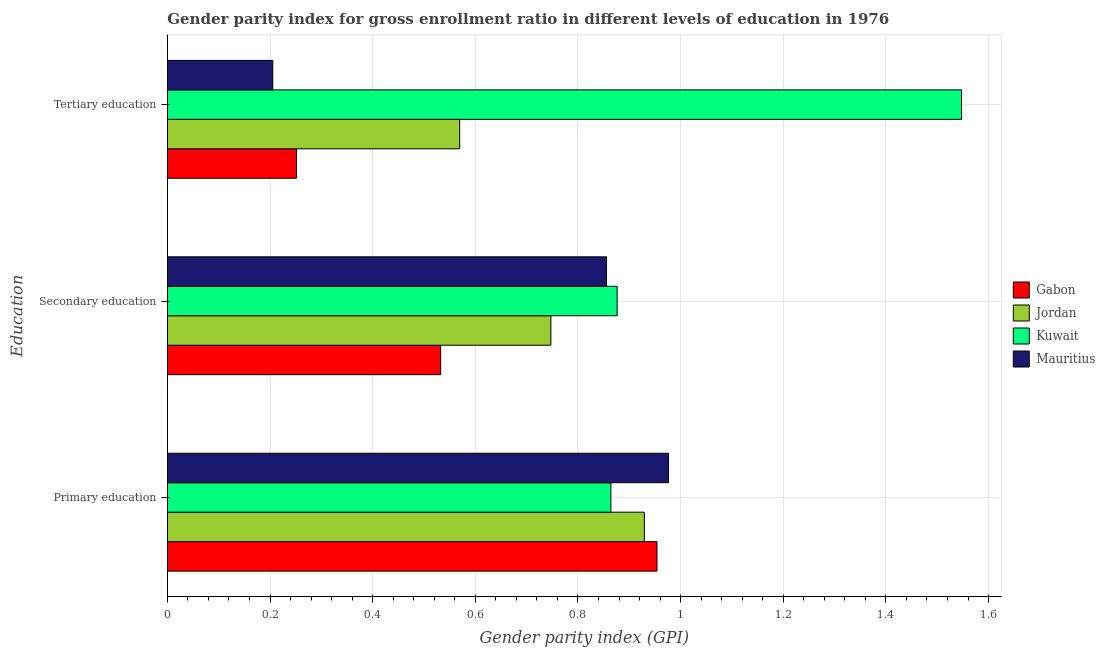How many groups of bars are there?
Provide a succinct answer. 3. Are the number of bars on each tick of the Y-axis equal?
Make the answer very short. Yes. How many bars are there on the 3rd tick from the top?
Keep it short and to the point. 4. What is the gender parity index in tertiary education in Gabon?
Ensure brevity in your answer.  0.25. Across all countries, what is the maximum gender parity index in secondary education?
Ensure brevity in your answer.  0.88. Across all countries, what is the minimum gender parity index in primary education?
Give a very brief answer. 0.86. In which country was the gender parity index in tertiary education maximum?
Make the answer very short. Kuwait. In which country was the gender parity index in tertiary education minimum?
Ensure brevity in your answer.  Mauritius. What is the total gender parity index in secondary education in the graph?
Make the answer very short. 3.01. What is the difference between the gender parity index in tertiary education in Mauritius and that in Gabon?
Keep it short and to the point. -0.05. What is the difference between the gender parity index in secondary education in Jordan and the gender parity index in tertiary education in Mauritius?
Provide a succinct answer. 0.54. What is the average gender parity index in primary education per country?
Offer a terse response. 0.93. What is the difference between the gender parity index in secondary education and gender parity index in primary education in Mauritius?
Offer a very short reply. -0.12. In how many countries, is the gender parity index in secondary education greater than 0.92 ?
Your response must be concise. 0. What is the ratio of the gender parity index in tertiary education in Jordan to that in Kuwait?
Your response must be concise. 0.37. Is the difference between the gender parity index in secondary education in Jordan and Kuwait greater than the difference between the gender parity index in tertiary education in Jordan and Kuwait?
Your response must be concise. Yes. What is the difference between the highest and the second highest gender parity index in primary education?
Give a very brief answer. 0.02. What is the difference between the highest and the lowest gender parity index in secondary education?
Offer a terse response. 0.34. Is the sum of the gender parity index in primary education in Kuwait and Gabon greater than the maximum gender parity index in secondary education across all countries?
Provide a short and direct response. Yes. What does the 1st bar from the top in Primary education represents?
Your answer should be very brief. Mauritius. What does the 2nd bar from the bottom in Tertiary education represents?
Give a very brief answer. Jordan. What is the difference between two consecutive major ticks on the X-axis?
Offer a terse response. 0.2. Does the graph contain grids?
Offer a terse response. Yes. What is the title of the graph?
Your answer should be very brief. Gender parity index for gross enrollment ratio in different levels of education in 1976. What is the label or title of the X-axis?
Your answer should be compact. Gender parity index (GPI). What is the label or title of the Y-axis?
Your answer should be very brief. Education. What is the Gender parity index (GPI) in Gabon in Primary education?
Keep it short and to the point. 0.95. What is the Gender parity index (GPI) in Jordan in Primary education?
Provide a succinct answer. 0.93. What is the Gender parity index (GPI) in Kuwait in Primary education?
Your response must be concise. 0.86. What is the Gender parity index (GPI) in Mauritius in Primary education?
Provide a succinct answer. 0.98. What is the Gender parity index (GPI) in Gabon in Secondary education?
Your answer should be very brief. 0.53. What is the Gender parity index (GPI) of Jordan in Secondary education?
Offer a very short reply. 0.75. What is the Gender parity index (GPI) in Kuwait in Secondary education?
Your response must be concise. 0.88. What is the Gender parity index (GPI) of Mauritius in Secondary education?
Give a very brief answer. 0.86. What is the Gender parity index (GPI) of Gabon in Tertiary education?
Provide a short and direct response. 0.25. What is the Gender parity index (GPI) of Jordan in Tertiary education?
Provide a short and direct response. 0.57. What is the Gender parity index (GPI) of Kuwait in Tertiary education?
Provide a succinct answer. 1.55. What is the Gender parity index (GPI) in Mauritius in Tertiary education?
Make the answer very short. 0.21. Across all Education, what is the maximum Gender parity index (GPI) of Gabon?
Offer a very short reply. 0.95. Across all Education, what is the maximum Gender parity index (GPI) in Jordan?
Provide a succinct answer. 0.93. Across all Education, what is the maximum Gender parity index (GPI) in Kuwait?
Provide a succinct answer. 1.55. Across all Education, what is the maximum Gender parity index (GPI) of Mauritius?
Make the answer very short. 0.98. Across all Education, what is the minimum Gender parity index (GPI) of Gabon?
Offer a terse response. 0.25. Across all Education, what is the minimum Gender parity index (GPI) in Jordan?
Provide a succinct answer. 0.57. Across all Education, what is the minimum Gender parity index (GPI) of Kuwait?
Offer a very short reply. 0.86. Across all Education, what is the minimum Gender parity index (GPI) of Mauritius?
Your answer should be very brief. 0.21. What is the total Gender parity index (GPI) of Gabon in the graph?
Keep it short and to the point. 1.74. What is the total Gender parity index (GPI) in Jordan in the graph?
Provide a succinct answer. 2.25. What is the total Gender parity index (GPI) of Kuwait in the graph?
Your response must be concise. 3.29. What is the total Gender parity index (GPI) in Mauritius in the graph?
Provide a short and direct response. 2.04. What is the difference between the Gender parity index (GPI) of Gabon in Primary education and that in Secondary education?
Offer a very short reply. 0.42. What is the difference between the Gender parity index (GPI) of Jordan in Primary education and that in Secondary education?
Provide a short and direct response. 0.18. What is the difference between the Gender parity index (GPI) of Kuwait in Primary education and that in Secondary education?
Make the answer very short. -0.01. What is the difference between the Gender parity index (GPI) in Mauritius in Primary education and that in Secondary education?
Ensure brevity in your answer.  0.12. What is the difference between the Gender parity index (GPI) of Gabon in Primary education and that in Tertiary education?
Your answer should be compact. 0.7. What is the difference between the Gender parity index (GPI) in Jordan in Primary education and that in Tertiary education?
Make the answer very short. 0.36. What is the difference between the Gender parity index (GPI) of Kuwait in Primary education and that in Tertiary education?
Give a very brief answer. -0.68. What is the difference between the Gender parity index (GPI) of Mauritius in Primary education and that in Tertiary education?
Your answer should be compact. 0.77. What is the difference between the Gender parity index (GPI) of Gabon in Secondary education and that in Tertiary education?
Offer a very short reply. 0.28. What is the difference between the Gender parity index (GPI) of Jordan in Secondary education and that in Tertiary education?
Give a very brief answer. 0.18. What is the difference between the Gender parity index (GPI) of Kuwait in Secondary education and that in Tertiary education?
Offer a very short reply. -0.67. What is the difference between the Gender parity index (GPI) of Mauritius in Secondary education and that in Tertiary education?
Offer a very short reply. 0.65. What is the difference between the Gender parity index (GPI) in Gabon in Primary education and the Gender parity index (GPI) in Jordan in Secondary education?
Ensure brevity in your answer.  0.21. What is the difference between the Gender parity index (GPI) of Gabon in Primary education and the Gender parity index (GPI) of Kuwait in Secondary education?
Your response must be concise. 0.08. What is the difference between the Gender parity index (GPI) in Gabon in Primary education and the Gender parity index (GPI) in Mauritius in Secondary education?
Provide a short and direct response. 0.1. What is the difference between the Gender parity index (GPI) of Jordan in Primary education and the Gender parity index (GPI) of Kuwait in Secondary education?
Ensure brevity in your answer.  0.05. What is the difference between the Gender parity index (GPI) of Jordan in Primary education and the Gender parity index (GPI) of Mauritius in Secondary education?
Your response must be concise. 0.07. What is the difference between the Gender parity index (GPI) of Kuwait in Primary education and the Gender parity index (GPI) of Mauritius in Secondary education?
Your answer should be very brief. 0.01. What is the difference between the Gender parity index (GPI) of Gabon in Primary education and the Gender parity index (GPI) of Jordan in Tertiary education?
Make the answer very short. 0.38. What is the difference between the Gender parity index (GPI) in Gabon in Primary education and the Gender parity index (GPI) in Kuwait in Tertiary education?
Offer a terse response. -0.59. What is the difference between the Gender parity index (GPI) of Gabon in Primary education and the Gender parity index (GPI) of Mauritius in Tertiary education?
Offer a very short reply. 0.75. What is the difference between the Gender parity index (GPI) in Jordan in Primary education and the Gender parity index (GPI) in Kuwait in Tertiary education?
Make the answer very short. -0.62. What is the difference between the Gender parity index (GPI) in Jordan in Primary education and the Gender parity index (GPI) in Mauritius in Tertiary education?
Offer a very short reply. 0.72. What is the difference between the Gender parity index (GPI) in Kuwait in Primary education and the Gender parity index (GPI) in Mauritius in Tertiary education?
Your answer should be very brief. 0.66. What is the difference between the Gender parity index (GPI) in Gabon in Secondary education and the Gender parity index (GPI) in Jordan in Tertiary education?
Provide a succinct answer. -0.04. What is the difference between the Gender parity index (GPI) of Gabon in Secondary education and the Gender parity index (GPI) of Kuwait in Tertiary education?
Keep it short and to the point. -1.01. What is the difference between the Gender parity index (GPI) in Gabon in Secondary education and the Gender parity index (GPI) in Mauritius in Tertiary education?
Offer a very short reply. 0.33. What is the difference between the Gender parity index (GPI) of Jordan in Secondary education and the Gender parity index (GPI) of Kuwait in Tertiary education?
Make the answer very short. -0.8. What is the difference between the Gender parity index (GPI) in Jordan in Secondary education and the Gender parity index (GPI) in Mauritius in Tertiary education?
Your answer should be compact. 0.54. What is the difference between the Gender parity index (GPI) in Kuwait in Secondary education and the Gender parity index (GPI) in Mauritius in Tertiary education?
Offer a very short reply. 0.67. What is the average Gender parity index (GPI) in Gabon per Education?
Your response must be concise. 0.58. What is the average Gender parity index (GPI) in Jordan per Education?
Provide a succinct answer. 0.75. What is the average Gender parity index (GPI) in Kuwait per Education?
Provide a succinct answer. 1.1. What is the average Gender parity index (GPI) of Mauritius per Education?
Offer a terse response. 0.68. What is the difference between the Gender parity index (GPI) of Gabon and Gender parity index (GPI) of Jordan in Primary education?
Your answer should be very brief. 0.02. What is the difference between the Gender parity index (GPI) in Gabon and Gender parity index (GPI) in Kuwait in Primary education?
Offer a very short reply. 0.09. What is the difference between the Gender parity index (GPI) of Gabon and Gender parity index (GPI) of Mauritius in Primary education?
Your response must be concise. -0.02. What is the difference between the Gender parity index (GPI) in Jordan and Gender parity index (GPI) in Kuwait in Primary education?
Keep it short and to the point. 0.07. What is the difference between the Gender parity index (GPI) of Jordan and Gender parity index (GPI) of Mauritius in Primary education?
Your answer should be compact. -0.05. What is the difference between the Gender parity index (GPI) in Kuwait and Gender parity index (GPI) in Mauritius in Primary education?
Your answer should be compact. -0.11. What is the difference between the Gender parity index (GPI) of Gabon and Gender parity index (GPI) of Jordan in Secondary education?
Give a very brief answer. -0.21. What is the difference between the Gender parity index (GPI) of Gabon and Gender parity index (GPI) of Kuwait in Secondary education?
Your answer should be compact. -0.34. What is the difference between the Gender parity index (GPI) of Gabon and Gender parity index (GPI) of Mauritius in Secondary education?
Offer a very short reply. -0.32. What is the difference between the Gender parity index (GPI) in Jordan and Gender parity index (GPI) in Kuwait in Secondary education?
Your answer should be very brief. -0.13. What is the difference between the Gender parity index (GPI) of Jordan and Gender parity index (GPI) of Mauritius in Secondary education?
Make the answer very short. -0.11. What is the difference between the Gender parity index (GPI) of Kuwait and Gender parity index (GPI) of Mauritius in Secondary education?
Provide a short and direct response. 0.02. What is the difference between the Gender parity index (GPI) of Gabon and Gender parity index (GPI) of Jordan in Tertiary education?
Your response must be concise. -0.32. What is the difference between the Gender parity index (GPI) of Gabon and Gender parity index (GPI) of Kuwait in Tertiary education?
Your answer should be compact. -1.3. What is the difference between the Gender parity index (GPI) of Gabon and Gender parity index (GPI) of Mauritius in Tertiary education?
Your answer should be compact. 0.05. What is the difference between the Gender parity index (GPI) in Jordan and Gender parity index (GPI) in Kuwait in Tertiary education?
Keep it short and to the point. -0.98. What is the difference between the Gender parity index (GPI) of Jordan and Gender parity index (GPI) of Mauritius in Tertiary education?
Ensure brevity in your answer.  0.36. What is the difference between the Gender parity index (GPI) of Kuwait and Gender parity index (GPI) of Mauritius in Tertiary education?
Provide a succinct answer. 1.34. What is the ratio of the Gender parity index (GPI) of Gabon in Primary education to that in Secondary education?
Ensure brevity in your answer.  1.79. What is the ratio of the Gender parity index (GPI) of Jordan in Primary education to that in Secondary education?
Your response must be concise. 1.24. What is the ratio of the Gender parity index (GPI) of Kuwait in Primary education to that in Secondary education?
Your answer should be compact. 0.99. What is the ratio of the Gender parity index (GPI) of Mauritius in Primary education to that in Secondary education?
Make the answer very short. 1.14. What is the ratio of the Gender parity index (GPI) in Gabon in Primary education to that in Tertiary education?
Keep it short and to the point. 3.79. What is the ratio of the Gender parity index (GPI) of Jordan in Primary education to that in Tertiary education?
Your answer should be compact. 1.63. What is the ratio of the Gender parity index (GPI) of Kuwait in Primary education to that in Tertiary education?
Ensure brevity in your answer.  0.56. What is the ratio of the Gender parity index (GPI) of Mauritius in Primary education to that in Tertiary education?
Offer a very short reply. 4.75. What is the ratio of the Gender parity index (GPI) in Gabon in Secondary education to that in Tertiary education?
Keep it short and to the point. 2.12. What is the ratio of the Gender parity index (GPI) in Jordan in Secondary education to that in Tertiary education?
Ensure brevity in your answer.  1.31. What is the ratio of the Gender parity index (GPI) in Kuwait in Secondary education to that in Tertiary education?
Offer a very short reply. 0.57. What is the ratio of the Gender parity index (GPI) in Mauritius in Secondary education to that in Tertiary education?
Keep it short and to the point. 4.17. What is the difference between the highest and the second highest Gender parity index (GPI) of Gabon?
Provide a succinct answer. 0.42. What is the difference between the highest and the second highest Gender parity index (GPI) in Jordan?
Offer a terse response. 0.18. What is the difference between the highest and the second highest Gender parity index (GPI) in Kuwait?
Offer a terse response. 0.67. What is the difference between the highest and the second highest Gender parity index (GPI) of Mauritius?
Provide a succinct answer. 0.12. What is the difference between the highest and the lowest Gender parity index (GPI) of Gabon?
Offer a very short reply. 0.7. What is the difference between the highest and the lowest Gender parity index (GPI) of Jordan?
Your answer should be very brief. 0.36. What is the difference between the highest and the lowest Gender parity index (GPI) of Kuwait?
Make the answer very short. 0.68. What is the difference between the highest and the lowest Gender parity index (GPI) of Mauritius?
Keep it short and to the point. 0.77. 